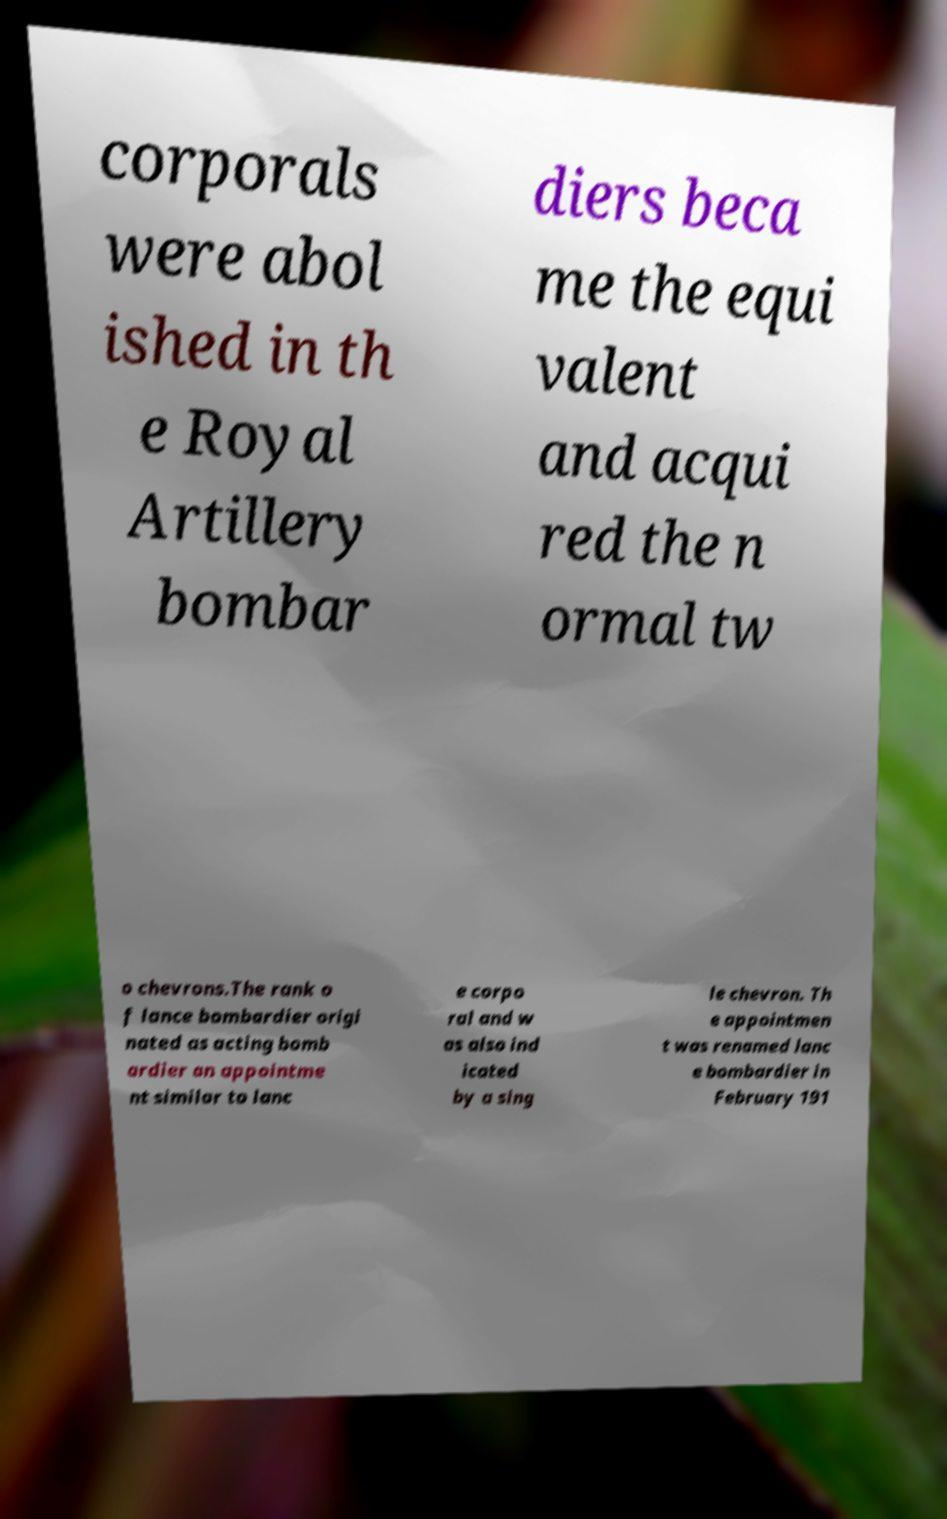There's text embedded in this image that I need extracted. Can you transcribe it verbatim? corporals were abol ished in th e Royal Artillery bombar diers beca me the equi valent and acqui red the n ormal tw o chevrons.The rank o f lance bombardier origi nated as acting bomb ardier an appointme nt similar to lanc e corpo ral and w as also ind icated by a sing le chevron. Th e appointmen t was renamed lanc e bombardier in February 191 